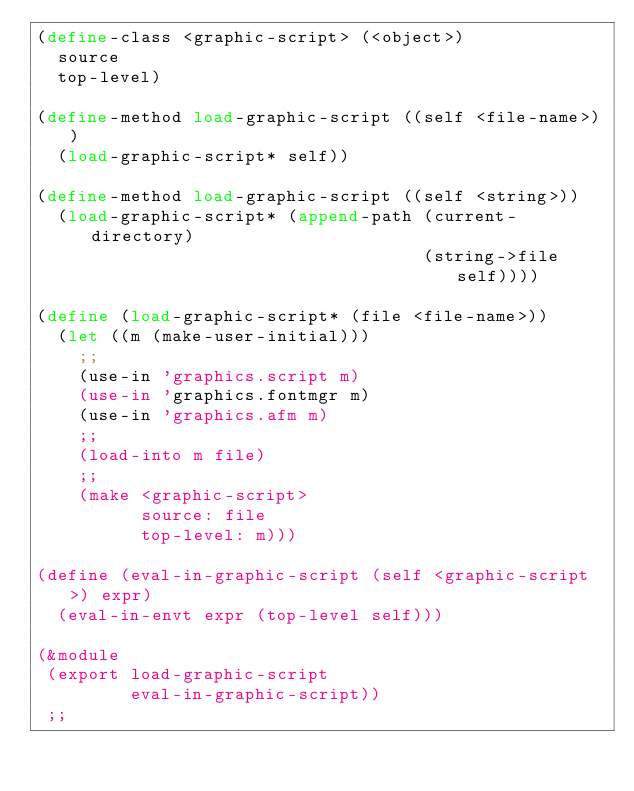Convert code to text. <code><loc_0><loc_0><loc_500><loc_500><_Scheme_>(define-class <graphic-script> (<object>)
  source
  top-level)

(define-method load-graphic-script ((self <file-name>))
  (load-graphic-script* self))

(define-method load-graphic-script ((self <string>))
  (load-graphic-script* (append-path (current-directory) 
                                     (string->file self))))

(define (load-graphic-script* (file <file-name>))
  (let ((m (make-user-initial)))
    ;;
    (use-in 'graphics.script m)
    (use-in 'graphics.fontmgr m)
    (use-in 'graphics.afm m)
    ;;
    (load-into m file)
    ;;
    (make <graphic-script>
          source: file
          top-level: m)))

(define (eval-in-graphic-script (self <graphic-script>) expr)
  (eval-in-envt expr (top-level self)))

(&module
 (export load-graphic-script
         eval-in-graphic-script))
 ;;
</code> 